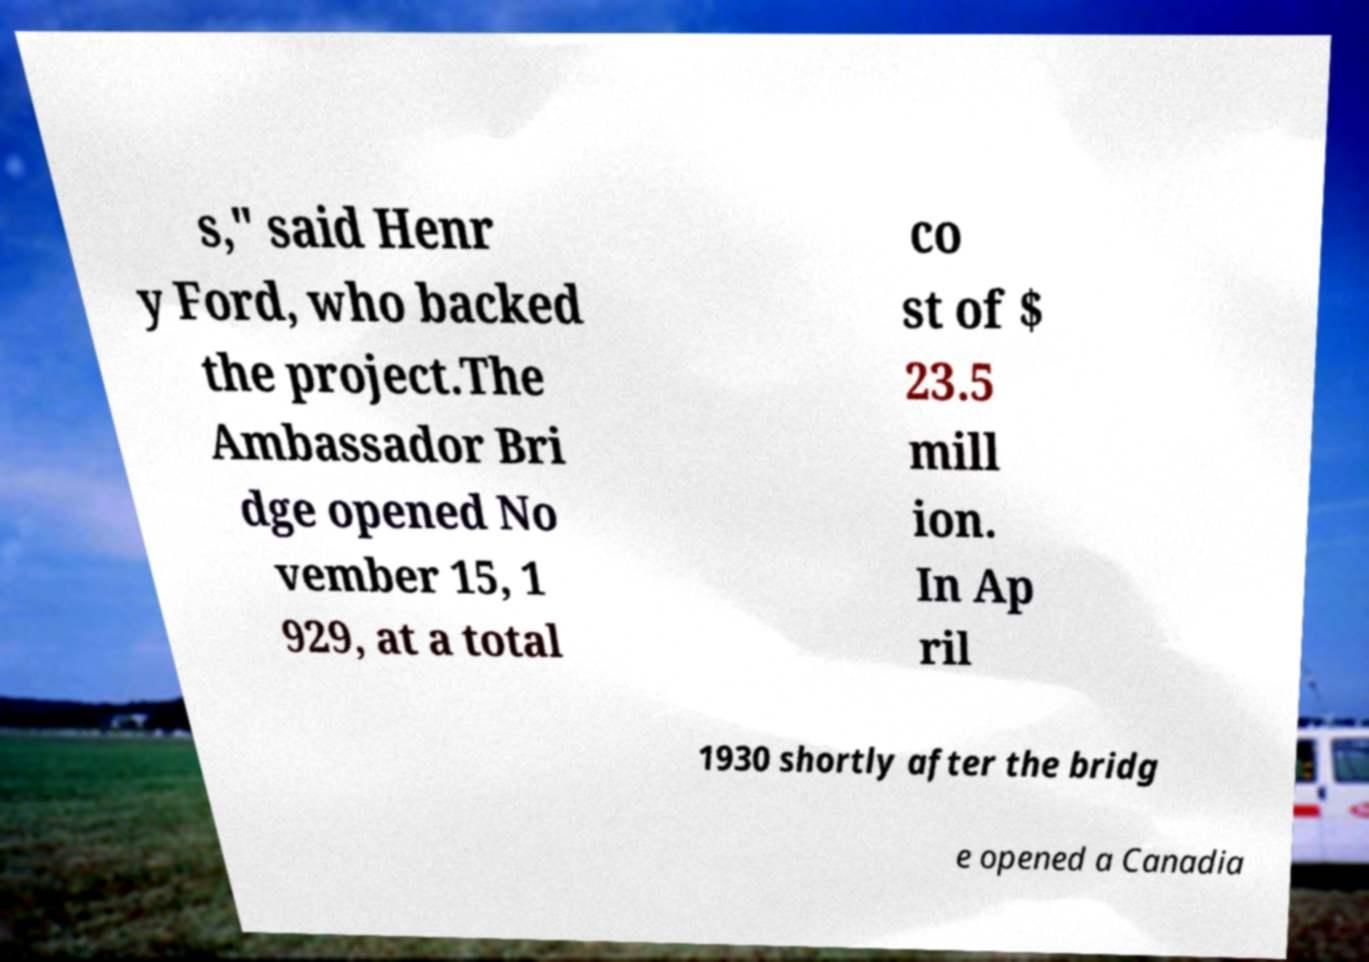Could you extract and type out the text from this image? s," said Henr y Ford, who backed the project.The Ambassador Bri dge opened No vember 15, 1 929, at a total co st of $ 23.5 mill ion. In Ap ril 1930 shortly after the bridg e opened a Canadia 